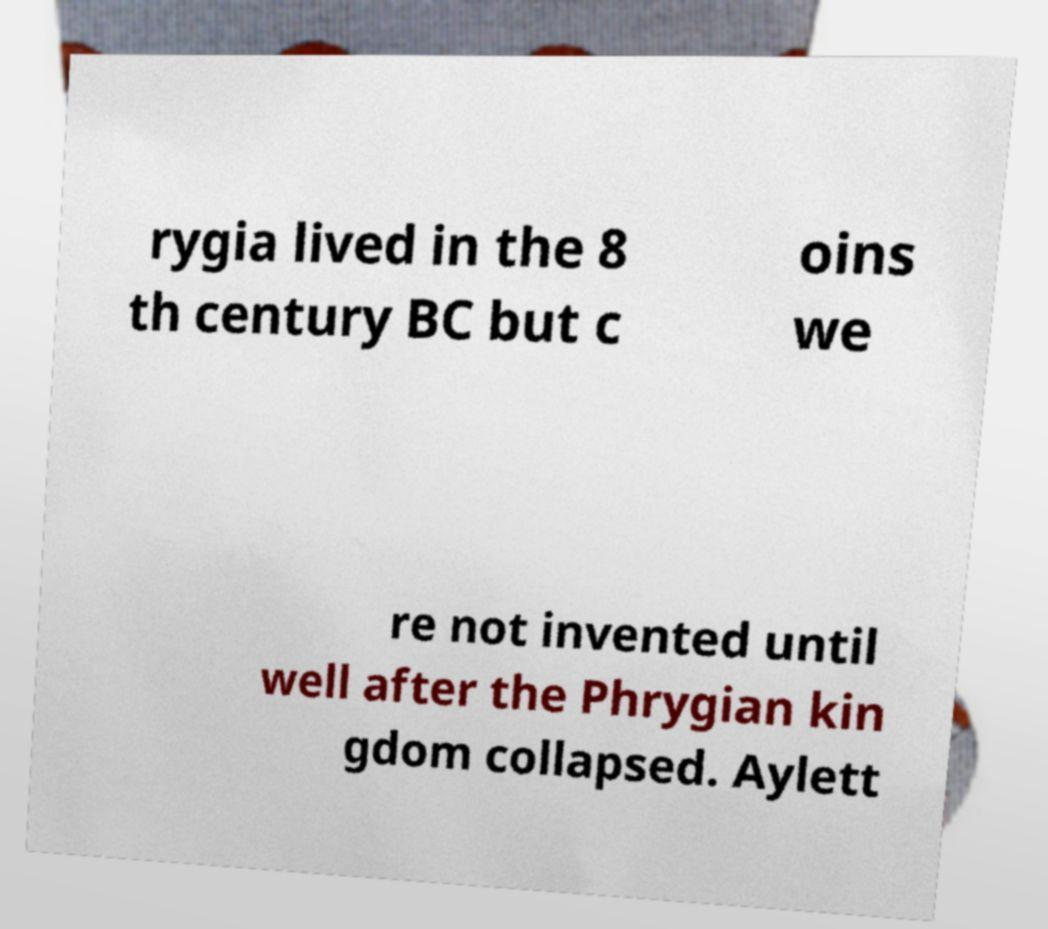I need the written content from this picture converted into text. Can you do that? rygia lived in the 8 th century BC but c oins we re not invented until well after the Phrygian kin gdom collapsed. Aylett 